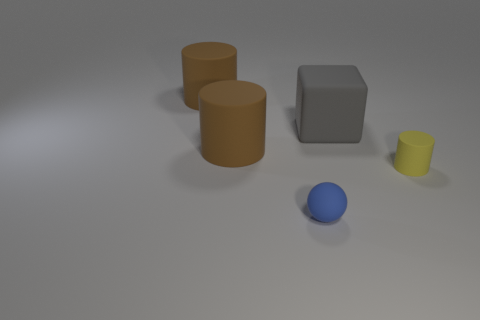Subtract all gray spheres. How many brown cylinders are left? 2 Subtract all large brown matte cylinders. How many cylinders are left? 1 Subtract all spheres. How many objects are left? 4 Add 4 big brown cylinders. How many objects exist? 9 Subtract all yellow cylinders. How many cylinders are left? 2 Subtract all cyan blocks. Subtract all red cylinders. How many blocks are left? 1 Subtract all big green matte balls. Subtract all big gray matte things. How many objects are left? 4 Add 4 large gray matte objects. How many large gray matte objects are left? 5 Add 4 small red cylinders. How many small red cylinders exist? 4 Subtract 0 gray cylinders. How many objects are left? 5 